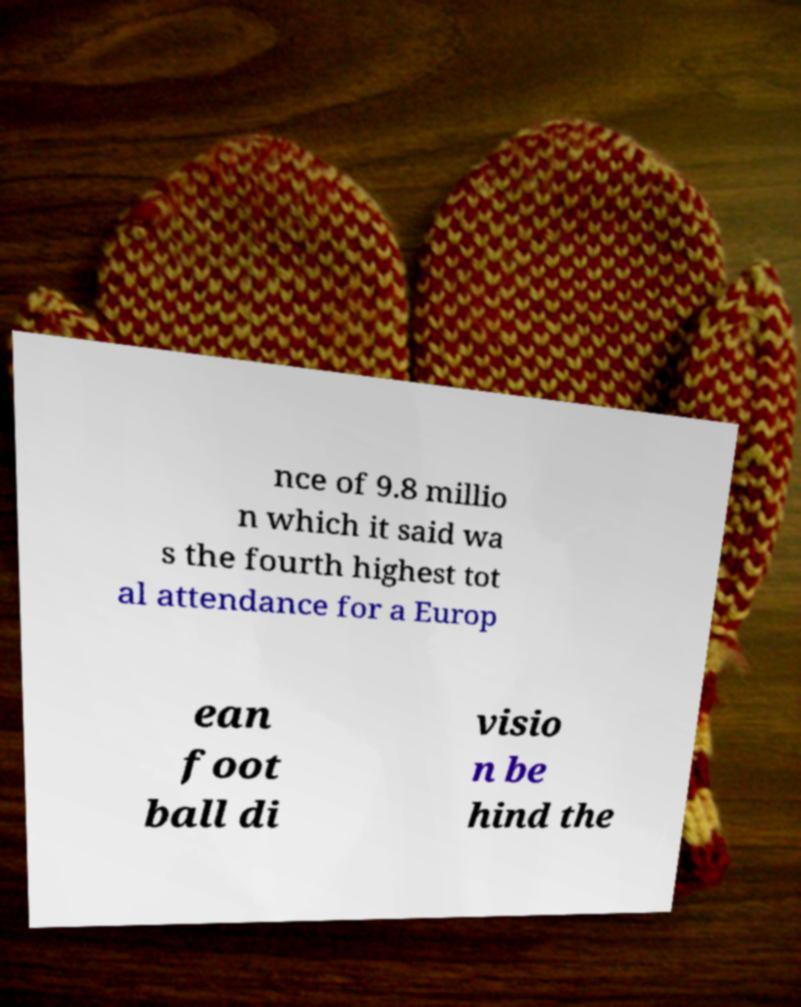Can you accurately transcribe the text from the provided image for me? nce of 9.8 millio n which it said wa s the fourth highest tot al attendance for a Europ ean foot ball di visio n be hind the 